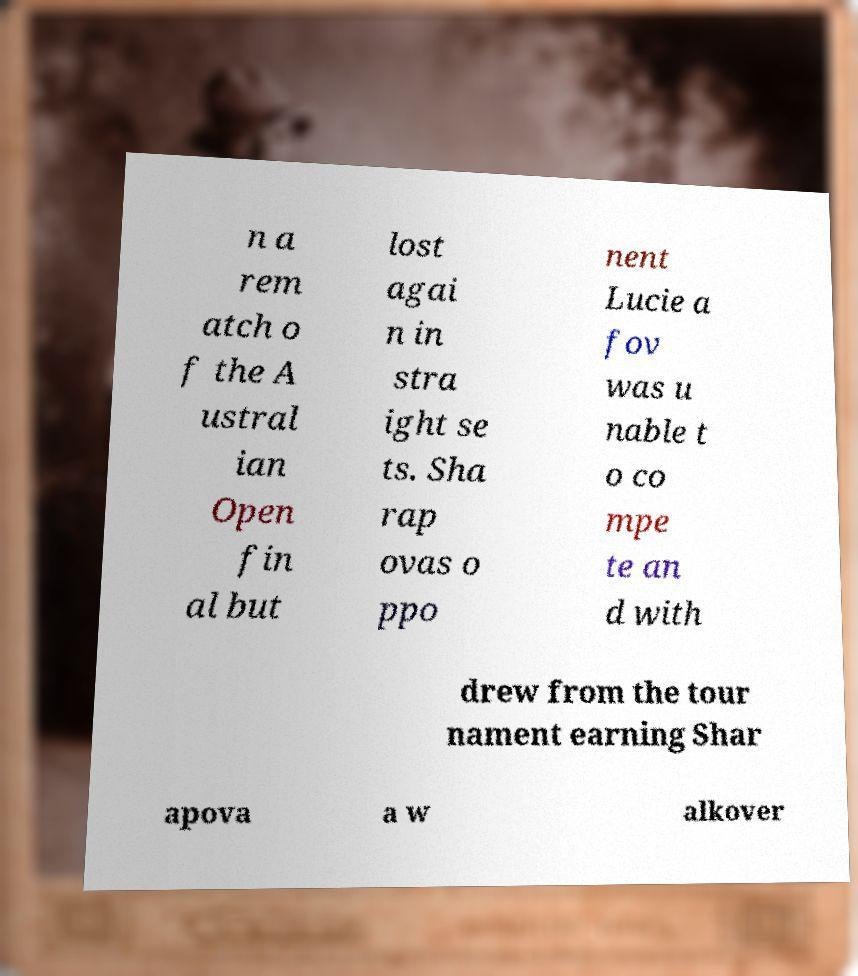Can you read and provide the text displayed in the image?This photo seems to have some interesting text. Can you extract and type it out for me? n a rem atch o f the A ustral ian Open fin al but lost agai n in stra ight se ts. Sha rap ovas o ppo nent Lucie a fov was u nable t o co mpe te an d with drew from the tour nament earning Shar apova a w alkover 